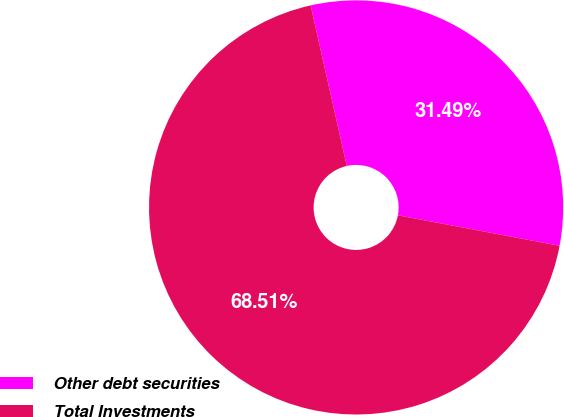Convert chart. <chart><loc_0><loc_0><loc_500><loc_500><pie_chart><fcel>Other debt securities<fcel>Total Investments<nl><fcel>31.49%<fcel>68.51%<nl></chart> 